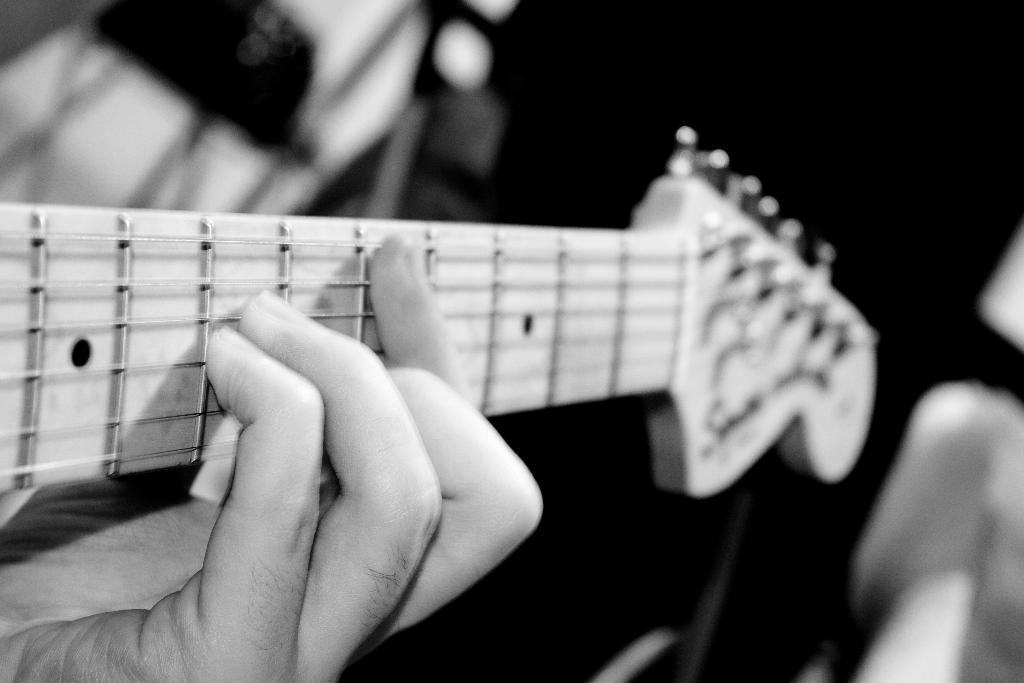What is the color scheme of the image? The image is black and white. What can be seen in the image? There is a person in the image. What is the person doing in the image? The person is playing a guitar. Can you see a sheep in the image? No, there is no sheep present in the image. Is there a fight happening between the person and the guitar in the image? No, there is no fight depicted in the image; the person is simply playing the guitar. 